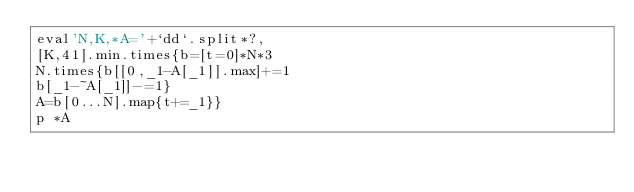<code> <loc_0><loc_0><loc_500><loc_500><_Ruby_>eval'N,K,*A='+`dd`.split*?,
[K,41].min.times{b=[t=0]*N*3
N.times{b[[0,_1-A[_1]].max]+=1
b[_1-~A[_1]]-=1}
A=b[0...N].map{t+=_1}}
p *A</code> 